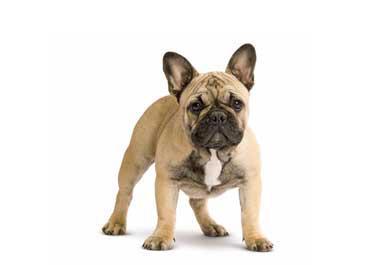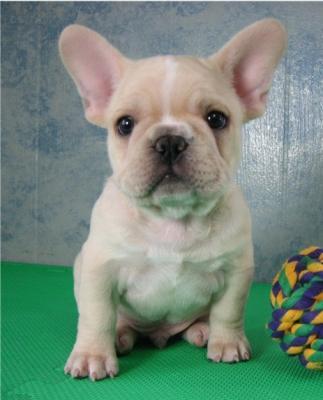The first image is the image on the left, the second image is the image on the right. For the images displayed, is the sentence "No less than one dog is outside." factually correct? Answer yes or no. No. The first image is the image on the left, the second image is the image on the right. Assess this claim about the two images: "Each image contains one bulldog, and the dog on the left is standing while the dog on the right is sitting.". Correct or not? Answer yes or no. Yes. 